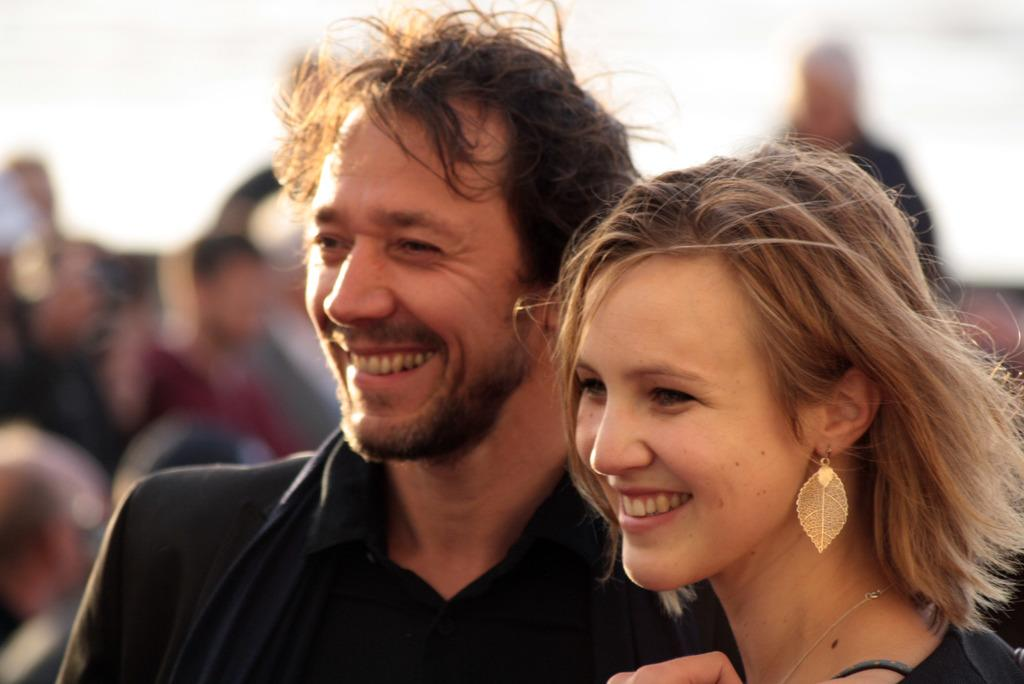How many people are present in the image? There are two people, a man and a woman, present in the image. What are the expressions of the man and woman in the image? Both the man and the woman are smiling in the image. Can you describe the people in the background of the image? The image is blurry, so it is difficult to describe the people in the background. What type of beef is being distributed to the people in the image? There is no beef or distribution of any kind present in the image. 